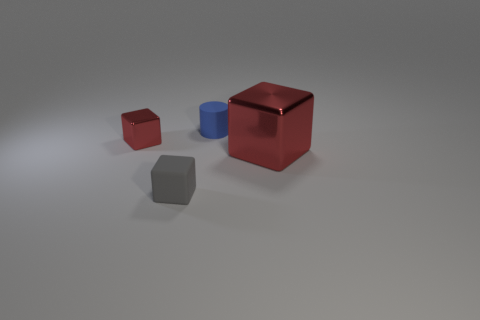Subtract all tiny blocks. How many blocks are left? 1 Add 2 large gray spheres. How many objects exist? 6 Subtract all cylinders. How many objects are left? 3 Subtract all red blocks. How many blocks are left? 1 Subtract all brown cubes. Subtract all yellow spheres. How many cubes are left? 3 Subtract all purple blocks. How many cyan cylinders are left? 0 Subtract all big yellow metal blocks. Subtract all tiny red objects. How many objects are left? 3 Add 4 small blue things. How many small blue things are left? 5 Add 4 big red cubes. How many big red cubes exist? 5 Subtract 0 brown blocks. How many objects are left? 4 